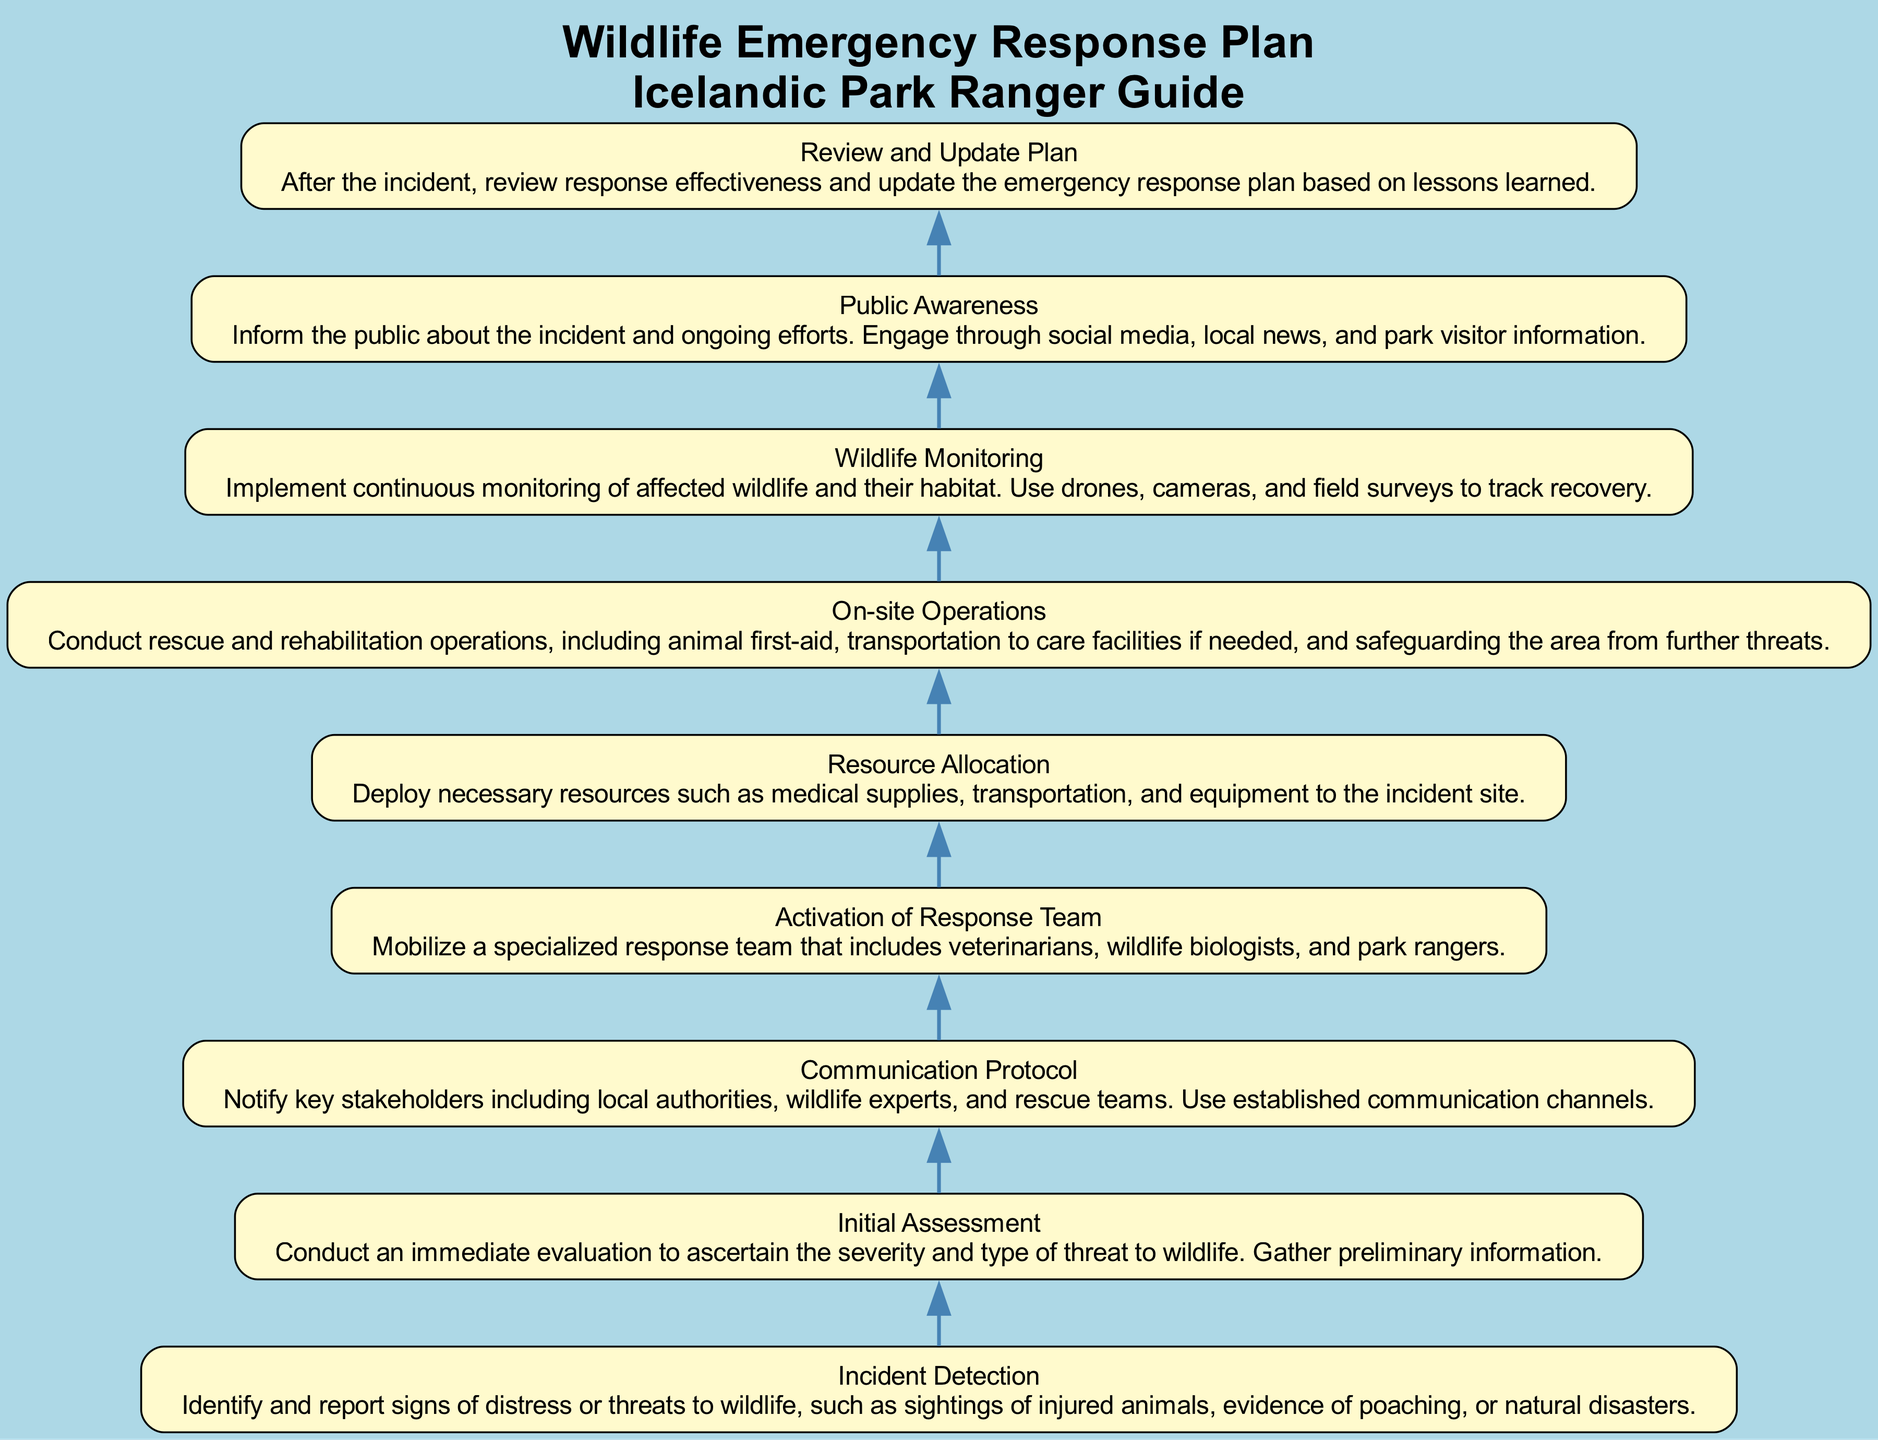What is the first step in the emergency response plan? The flowchart starts with "Incident Detection," which is the first node identified in the diagram.
Answer: Incident Detection How many nodes are there in the diagram? By counting each unique step in the emergency response plan, we find there are 9 nodes total: Incident Detection, Initial Assessment, Communication Protocol, Activation of Response Team, Resource Allocation, On-site Operations, Wildlife Monitoring, Public Awareness, and Review and Update Plan.
Answer: 9 What comes after "Wildlife Monitoring"? The flowchart indicates that after "Wildlife Monitoring," the next step is "Public Awareness," as indicated by the connection in the diagram.
Answer: Public Awareness Who is part of the specialized response team? The step "Activation of Response Team" specifies the inclusion of veterinarians, wildlife biologists, and park rangers as members of the specialized response team.
Answer: Veterinarians, wildlife biologists, park rangers What action is taken during the "On-site Operations" step? "On-site Operations" describes the actions of conducting rescue and rehabilitation operations, including animal first-aid and transportation to care facilities if needed.
Answer: Rescue and rehabilitation operations What is the primary purpose of the "Public Awareness" step? The aim of the "Public Awareness" step is to inform the public about the incident and ongoing efforts, as indicated in the description associated with that node.
Answer: Informing the public How does the plan ensure continuous monitoring of wildlife? The "Wildlife Monitoring" step emphasizes implementing continuous monitoring using drones, cameras, and field surveys to track recovery of the affected wildlife and habitat.
Answer: Drones, cameras, field surveys What is the last step in the emergency response plan? The last step identified in the flowchart is "Review and Update Plan," which indicates that this is the final action taken after responding to the incident.
Answer: Review and Update Plan What type of incidents does the plan address? The initial step "Incident Detection" specifically mentions signs of distress or threats to wildlife, including poaching and natural disasters, indicating the kind of incidents addressed by the plan.
Answer: Distress or threats to wildlife 